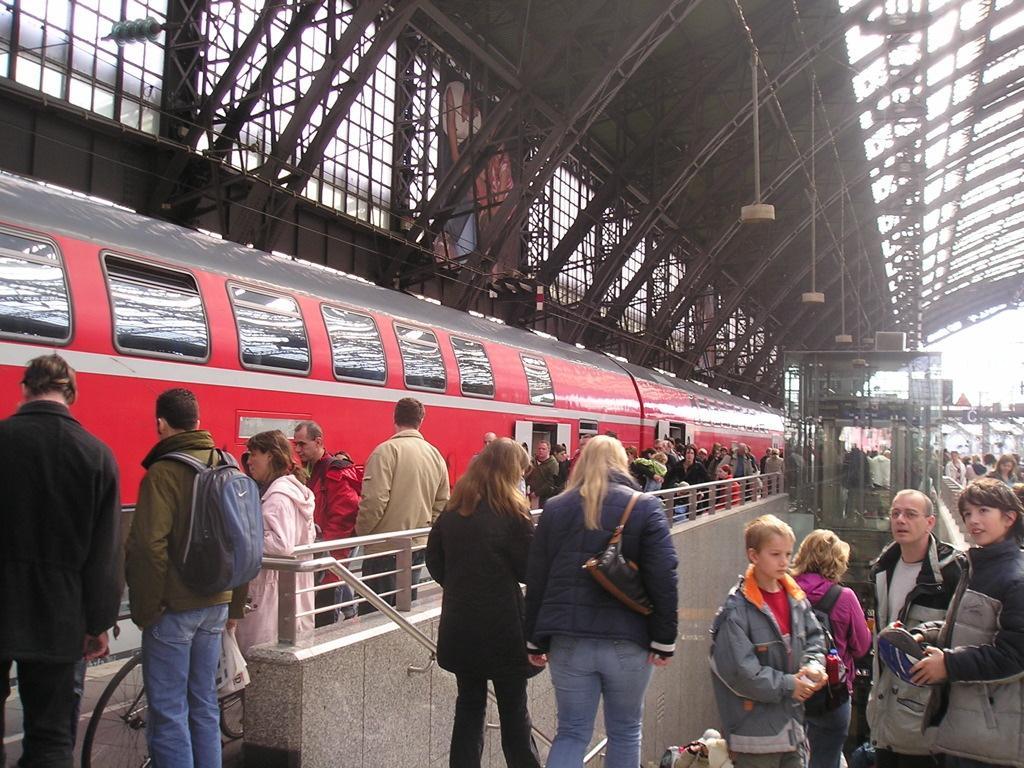In one or two sentences, can you explain what this image depicts? In this picture I can observe some people on the railway station platform. I can observe red color train in the middle of the picture. There are men and women in this picture. 